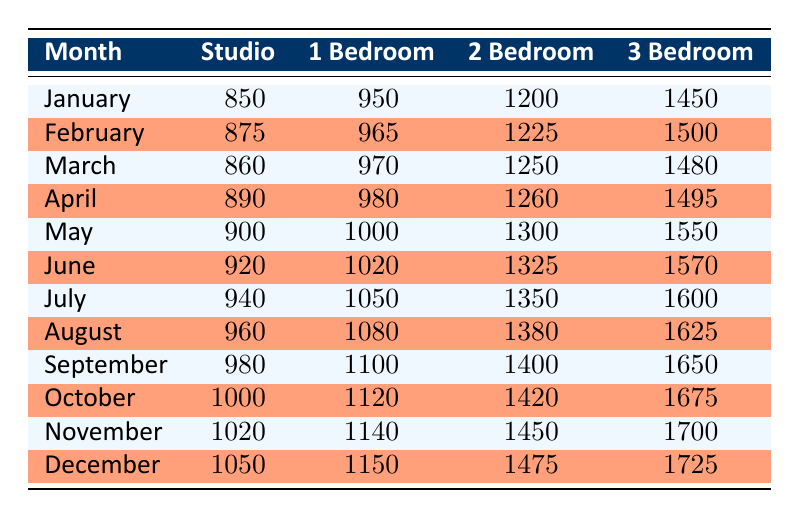What was the rental income for a 2-bedroom property in July? The rental income for a 2-bedroom property in July is located in the row for July under the 2-bedroom column. According to the table, it is 1350.
Answer: 1350 What is the rental income trend for studios from January to December? The rental income for studios starts at 850 in January and increases steadily to 1050 in December, showing a consistent upward trend throughout the year.
Answer: Increasing What is the difference in rental income between 3-bedroom properties in January and December? The rental income for 3-bedroom properties in January is 1450 and in December it is 1725. To find the difference, subtract January's figure from December's: 1725 - 1450 = 275.
Answer: 275 Which month had the highest rental income for a 1-bedroom property, and what was that amount? The 1-bedroom rental income increases monthly. Looking at the table, December shows the highest figure at 1150.
Answer: December, 1150 What is the average rental income for 2-bedroom properties across all months? To calculate the average 2-bedroom rental income, sum the monthly incomes (1200 + 1225 + 1250 + 1260 + 1300 + 1325 + 1350 + 1380 + 1400 + 1420 + 1450 + 1475) and divide by 12. The sum is 15340. Therefore, the average is 15340 / 12 = 1278.33.
Answer: 1278.33 Is the rental income for studios consistently lower than that for 1-bedroom properties throughout the year? By comparing the values for studios and 1-bedroom properties in each month, it is evident that studio rental income is lower every month compared to 1-bedroom prices, confirming that the statement is true.
Answer: Yes What is the maximum rental income for a studio and in which month does it occur? The maximum studio rental income is found by checking the last month, December, where it reaches 1050, confirming that is the highest value for the year.
Answer: 1050, December What was the combined rental income for a 3-bedroom property over the first half of the year (January to June)? To calculate the combined income, sum the amounts for the first half: 1450 (Jan) + 1500 (Feb) + 1480 (Mar) + 1495 (Apr) + 1550 (May) + 1570 (Jun) = 8195.
Answer: 8195 